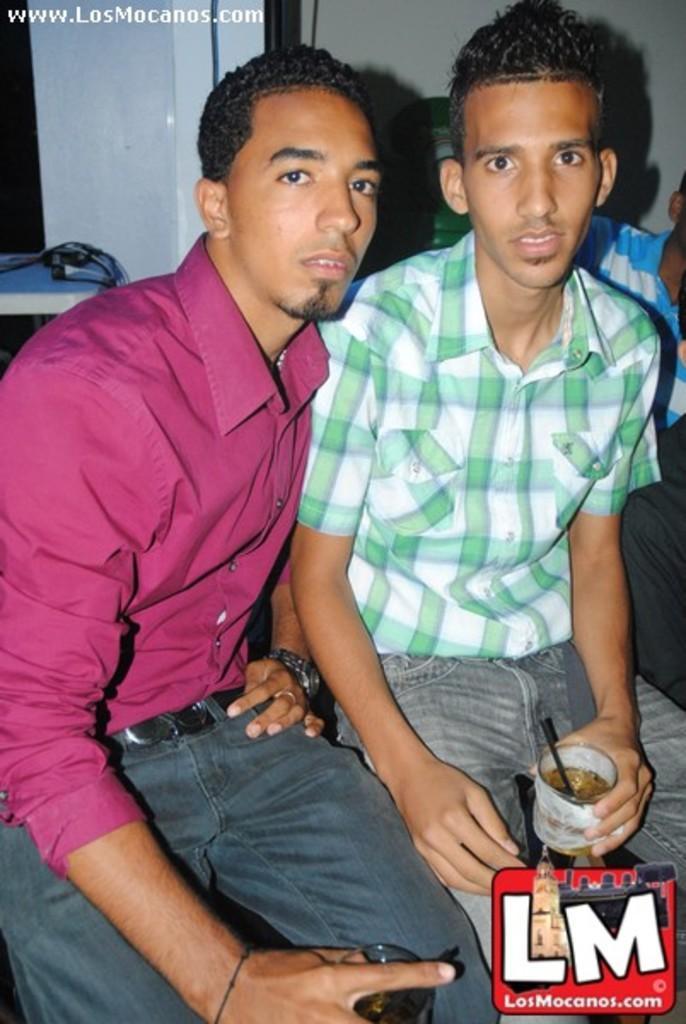How would you summarize this image in a sentence or two? In this picture we can see two boys sitting in the image holding a cup in the hand and giving a pose into the camera. In the front bottom side we can see a watermark quote. 